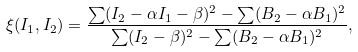<formula> <loc_0><loc_0><loc_500><loc_500>\xi ( I _ { 1 } , I _ { 2 } ) = \frac { \sum ( I _ { 2 } - \alpha I _ { 1 } - \beta ) ^ { 2 } - \sum ( B _ { 2 } - \alpha B _ { 1 } ) ^ { 2 } } { \sum ( I _ { 2 } - \beta ) ^ { 2 } - \sum ( B _ { 2 } - \alpha B _ { 1 } ) ^ { 2 } } ,</formula> 